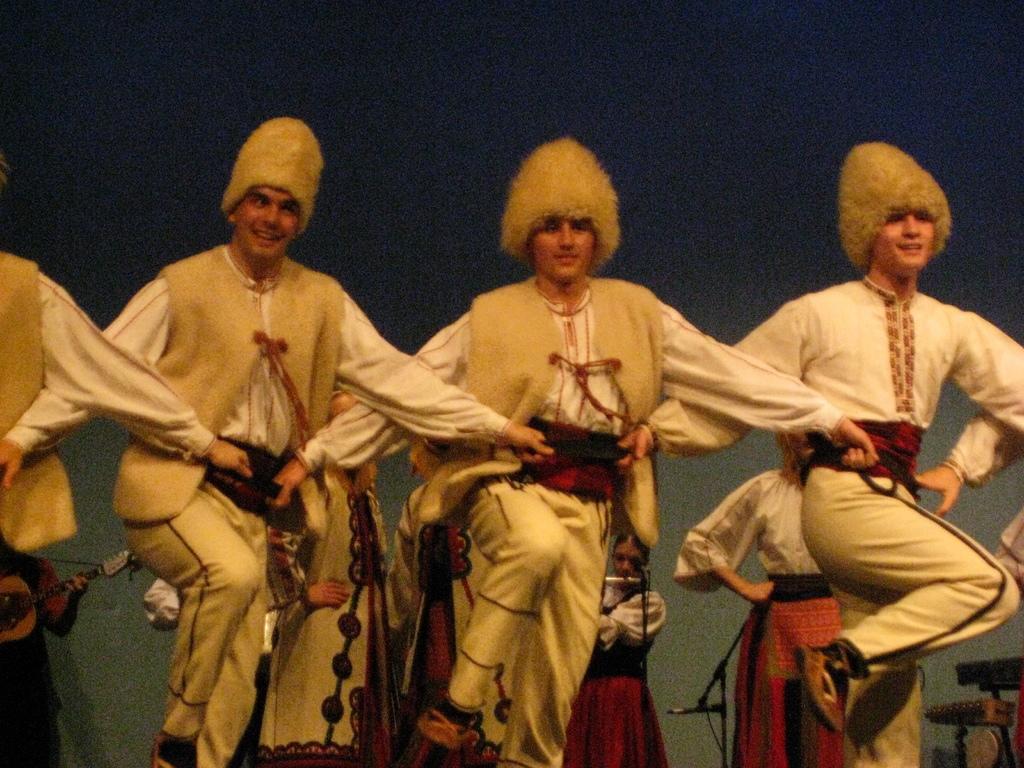How would you summarize this image in a sentence or two? In the picture we can see some group of men wearing similar dress dancing and in the background there are some women who are playing musical instruments and there is dark view. 